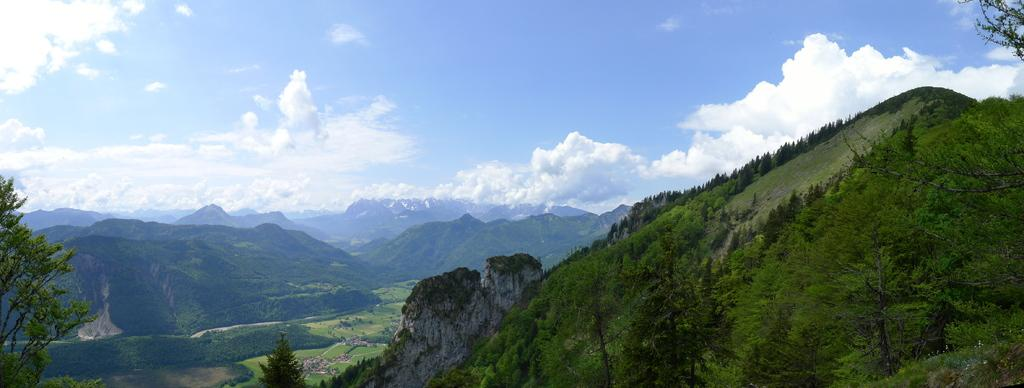What type of landscape feature can be seen in the image? There are hills in the image. What is visible in the sky in the image? There are clouds in the sky in the image. Can you see a flock of birds flying over the hills in the image? There is no mention of birds or any flock in the image, so we cannot confirm their presence. 